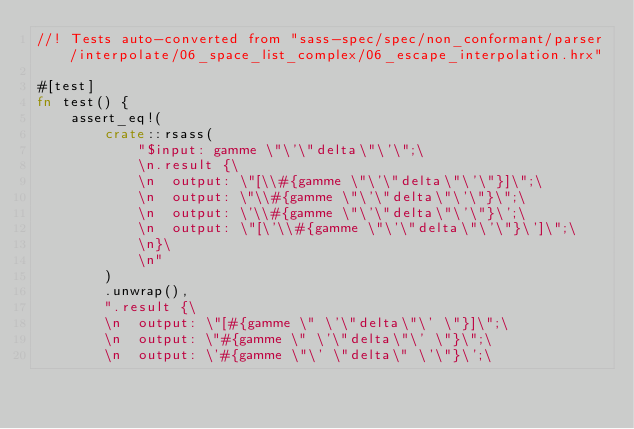<code> <loc_0><loc_0><loc_500><loc_500><_Rust_>//! Tests auto-converted from "sass-spec/spec/non_conformant/parser/interpolate/06_space_list_complex/06_escape_interpolation.hrx"

#[test]
fn test() {
    assert_eq!(
        crate::rsass(
            "$input: gamme \"\'\"delta\"\'\";\
            \n.result {\
            \n  output: \"[\\#{gamme \"\'\"delta\"\'\"}]\";\
            \n  output: \"\\#{gamme \"\'\"delta\"\'\"}\";\
            \n  output: \'\\#{gamme \"\'\"delta\"\'\"}\';\
            \n  output: \"[\'\\#{gamme \"\'\"delta\"\'\"}\']\";\
            \n}\
            \n"
        )
        .unwrap(),
        ".result {\
        \n  output: \"[#{gamme \" \'\"delta\"\' \"}]\";\
        \n  output: \"#{gamme \" \'\"delta\"\' \"}\";\
        \n  output: \'#{gamme \"\' \"delta\" \'\"}\';\</code> 